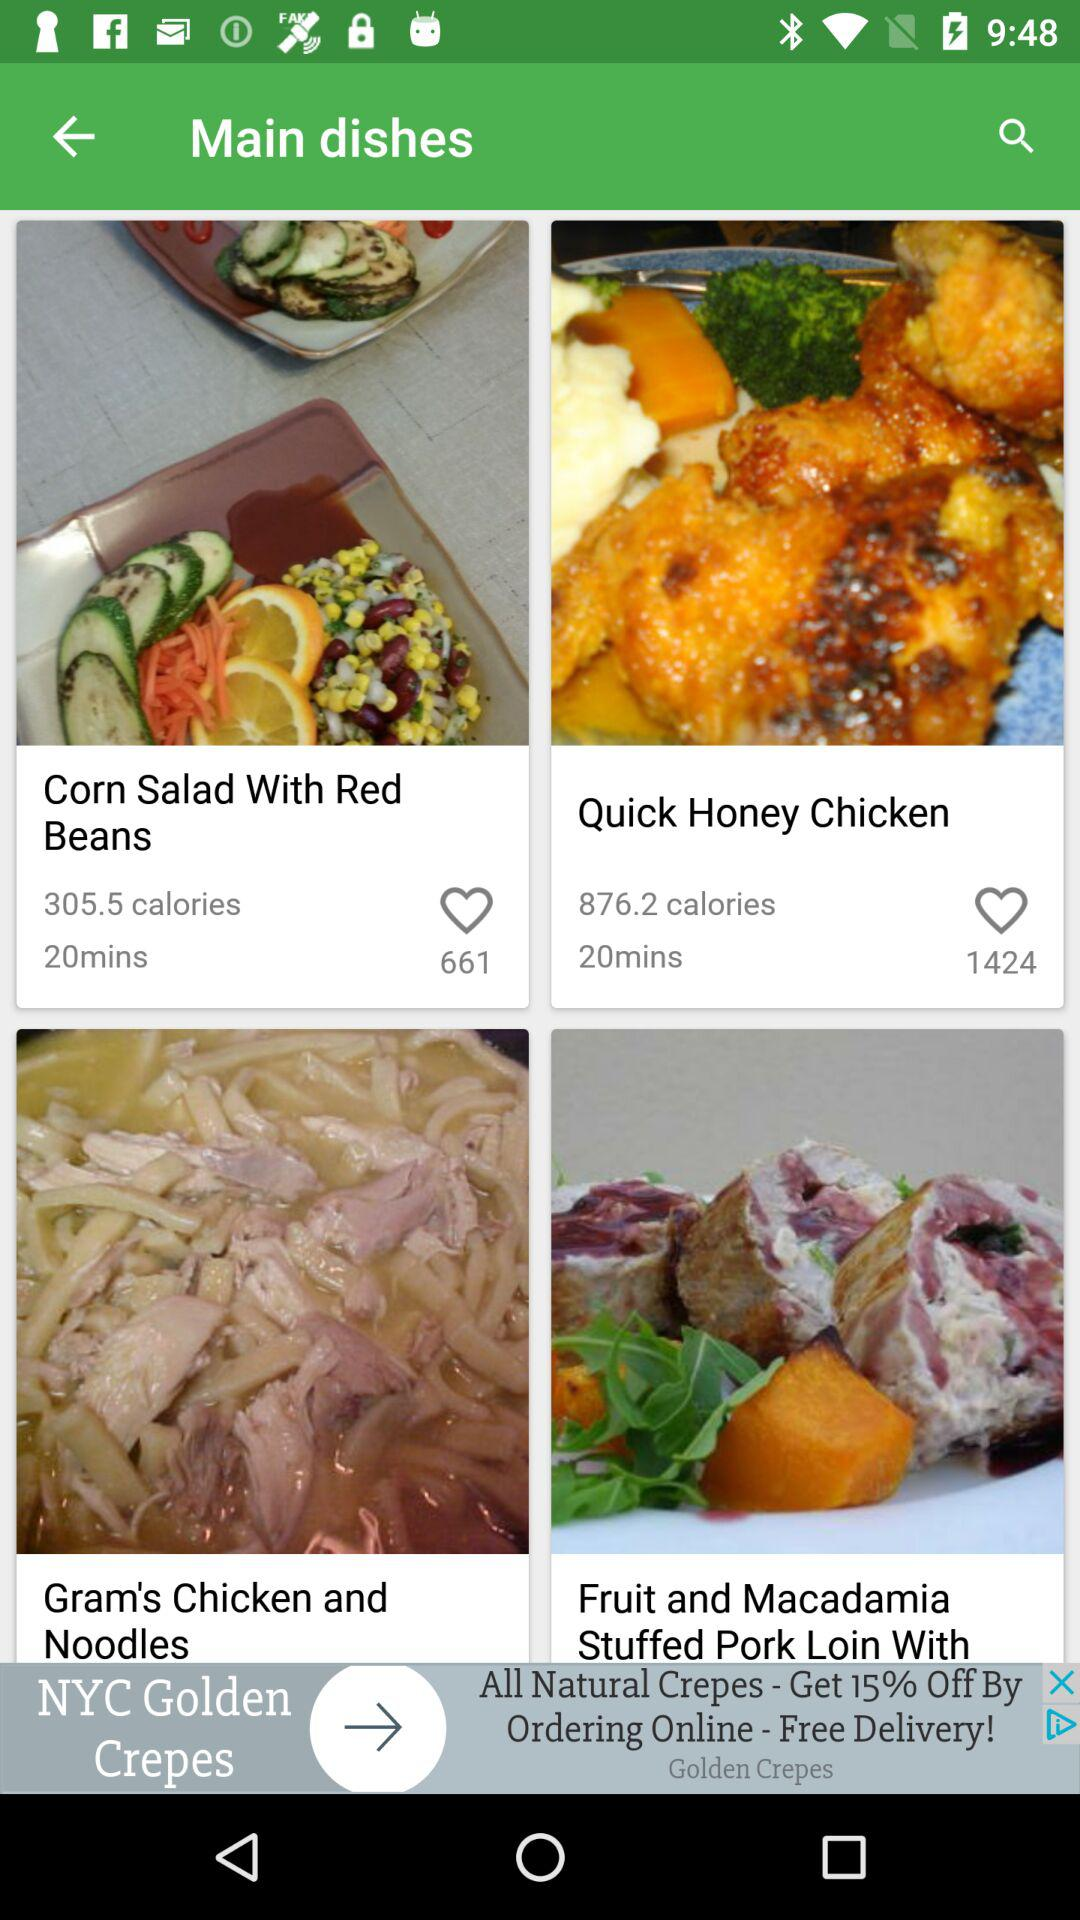Which dish has 661 likes? The dish that has 661 likes is "Corn Salad With Red Beans". 